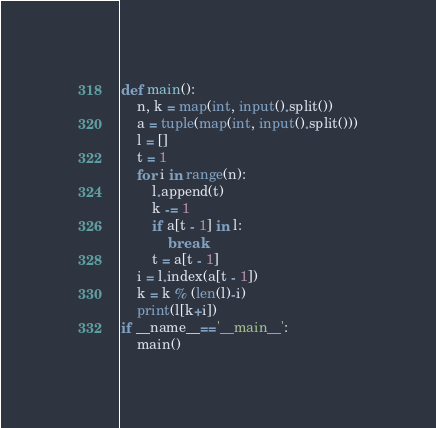<code> <loc_0><loc_0><loc_500><loc_500><_Python_>def main():
    n, k = map(int, input().split())
    a = tuple(map(int, input().split()))
    l = []
    t = 1
    for i in range(n):
        l.append(t)
        k -= 1
        if a[t - 1] in l:
            break
        t = a[t - 1]
    i = l.index(a[t - 1])
    k = k % (len(l)-i)
    print(l[k+i])
if __name__=='__main__':
    main()</code> 